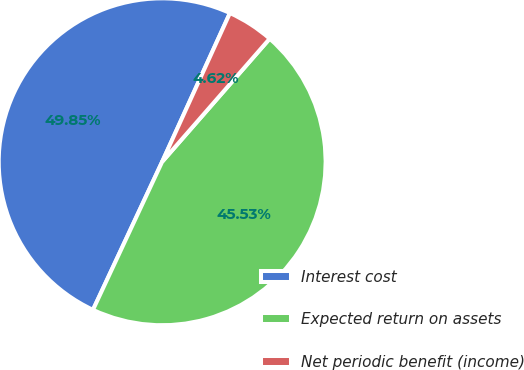<chart> <loc_0><loc_0><loc_500><loc_500><pie_chart><fcel>Interest cost<fcel>Expected return on assets<fcel>Net periodic benefit (income)<nl><fcel>49.85%<fcel>45.53%<fcel>4.62%<nl></chart> 